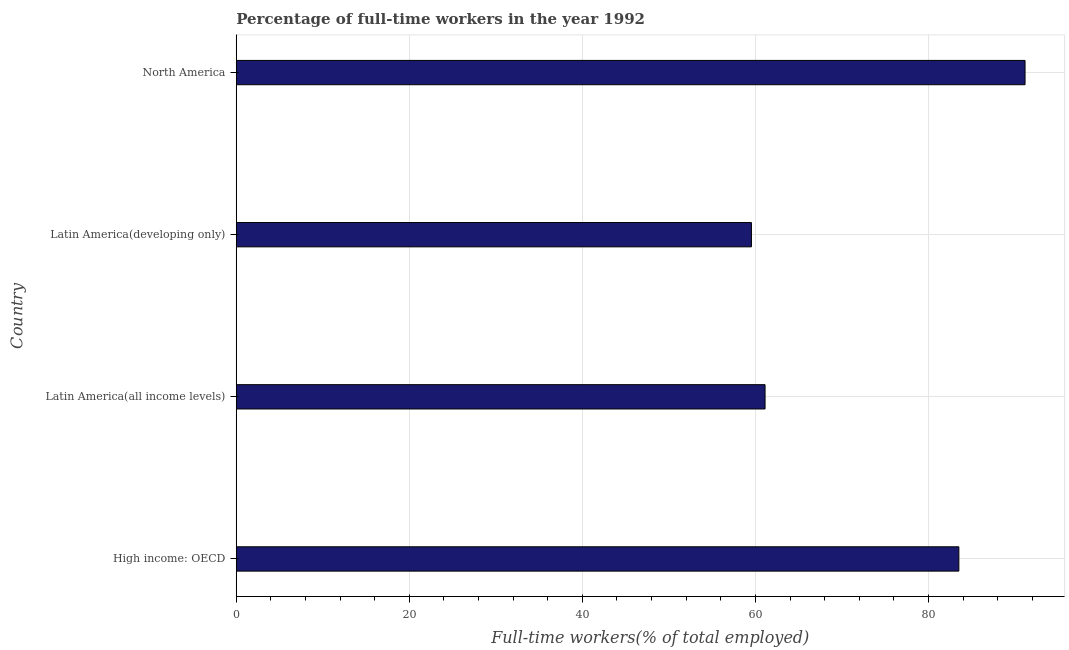Does the graph contain any zero values?
Offer a terse response. No. What is the title of the graph?
Ensure brevity in your answer.  Percentage of full-time workers in the year 1992. What is the label or title of the X-axis?
Your answer should be very brief. Full-time workers(% of total employed). What is the percentage of full-time workers in Latin America(developing only)?
Offer a terse response. 59.54. Across all countries, what is the maximum percentage of full-time workers?
Your answer should be compact. 91.16. Across all countries, what is the minimum percentage of full-time workers?
Provide a succinct answer. 59.54. In which country was the percentage of full-time workers minimum?
Make the answer very short. Latin America(developing only). What is the sum of the percentage of full-time workers?
Make the answer very short. 295.33. What is the difference between the percentage of full-time workers in Latin America(all income levels) and North America?
Ensure brevity in your answer.  -30.05. What is the average percentage of full-time workers per country?
Make the answer very short. 73.83. What is the median percentage of full-time workers?
Provide a short and direct response. 72.31. In how many countries, is the percentage of full-time workers greater than 72 %?
Offer a terse response. 2. What is the ratio of the percentage of full-time workers in High income: OECD to that in North America?
Offer a terse response. 0.92. Is the percentage of full-time workers in High income: OECD less than that in North America?
Ensure brevity in your answer.  Yes. What is the difference between the highest and the second highest percentage of full-time workers?
Offer a terse response. 7.65. What is the difference between the highest and the lowest percentage of full-time workers?
Your answer should be very brief. 31.62. In how many countries, is the percentage of full-time workers greater than the average percentage of full-time workers taken over all countries?
Provide a succinct answer. 2. Are all the bars in the graph horizontal?
Offer a terse response. Yes. What is the difference between two consecutive major ticks on the X-axis?
Give a very brief answer. 20. What is the Full-time workers(% of total employed) of High income: OECD?
Ensure brevity in your answer.  83.51. What is the Full-time workers(% of total employed) in Latin America(all income levels)?
Your response must be concise. 61.12. What is the Full-time workers(% of total employed) in Latin America(developing only)?
Your answer should be very brief. 59.54. What is the Full-time workers(% of total employed) in North America?
Ensure brevity in your answer.  91.16. What is the difference between the Full-time workers(% of total employed) in High income: OECD and Latin America(all income levels)?
Your answer should be compact. 22.4. What is the difference between the Full-time workers(% of total employed) in High income: OECD and Latin America(developing only)?
Make the answer very short. 23.97. What is the difference between the Full-time workers(% of total employed) in High income: OECD and North America?
Your answer should be compact. -7.65. What is the difference between the Full-time workers(% of total employed) in Latin America(all income levels) and Latin America(developing only)?
Your answer should be very brief. 1.57. What is the difference between the Full-time workers(% of total employed) in Latin America(all income levels) and North America?
Your answer should be very brief. -30.05. What is the difference between the Full-time workers(% of total employed) in Latin America(developing only) and North America?
Keep it short and to the point. -31.62. What is the ratio of the Full-time workers(% of total employed) in High income: OECD to that in Latin America(all income levels)?
Your answer should be compact. 1.37. What is the ratio of the Full-time workers(% of total employed) in High income: OECD to that in Latin America(developing only)?
Your answer should be very brief. 1.4. What is the ratio of the Full-time workers(% of total employed) in High income: OECD to that in North America?
Your response must be concise. 0.92. What is the ratio of the Full-time workers(% of total employed) in Latin America(all income levels) to that in Latin America(developing only)?
Ensure brevity in your answer.  1.03. What is the ratio of the Full-time workers(% of total employed) in Latin America(all income levels) to that in North America?
Offer a very short reply. 0.67. What is the ratio of the Full-time workers(% of total employed) in Latin America(developing only) to that in North America?
Provide a succinct answer. 0.65. 